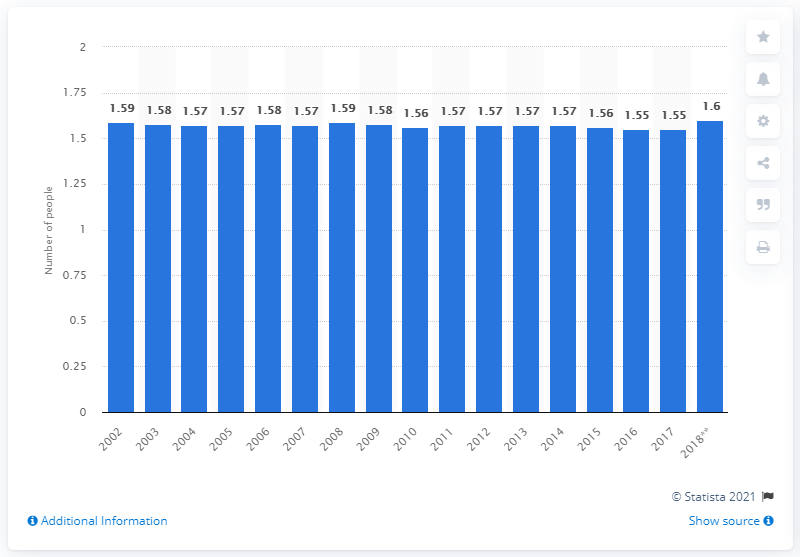Identify some key points in this picture. In 2017, there were approximately 1.55 people in a car or van in England. In 2018, the average occupancy of cars and vans in England was 1.6 passengers per vehicle. 